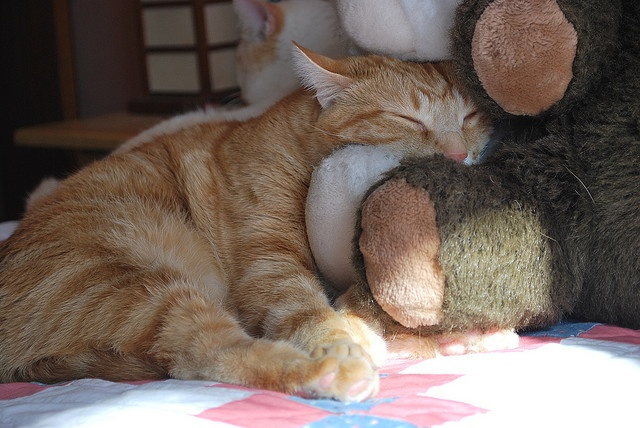Describe the objects in this image and their specific colors. I can see cat in black, gray, and maroon tones, teddy bear in black, gray, and maroon tones, and bed in black, white, darkgray, pink, and lightblue tones in this image. 